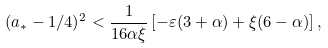<formula> <loc_0><loc_0><loc_500><loc_500>( a _ { * } - 1 / 4 ) ^ { 2 } < \frac { 1 } { 1 6 \alpha \xi } \left [ - \varepsilon ( 3 + \alpha ) + \xi ( 6 - \alpha ) \right ] ,</formula> 